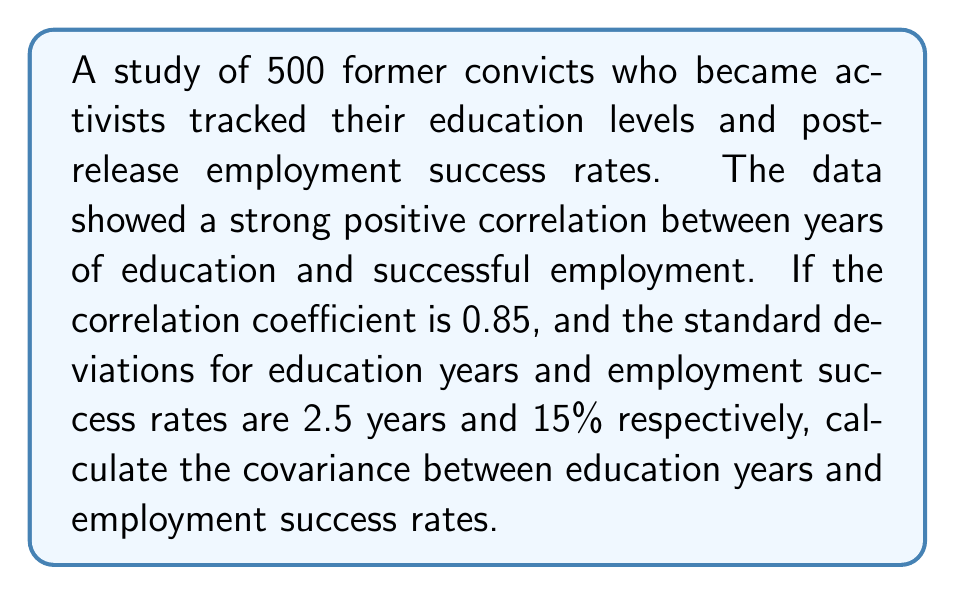Show me your answer to this math problem. To solve this problem, we'll use the formula for the correlation coefficient in terms of covariance and standard deviations:

$$r = \frac{\text{Cov}(X,Y)}{\sigma_X \sigma_Y}$$

Where:
$r$ is the correlation coefficient
$\text{Cov}(X,Y)$ is the covariance between X and Y
$\sigma_X$ is the standard deviation of X
$\sigma_Y$ is the standard deviation of Y

We're given:
$r = 0.85$
$\sigma_X = 2.5$ years (education)
$\sigma_Y = 15\%$ (employment success rate)

Let's rearrange the formula to solve for covariance:

$$\text{Cov}(X,Y) = r \cdot \sigma_X \cdot \sigma_Y$$

Now, we can substitute the known values:

$$\text{Cov}(X,Y) = 0.85 \cdot 2.5 \cdot 15$$

Calculating:

$$\text{Cov}(X,Y) = 31.875$$

The units for covariance are the product of the units of the two variables, so in this case, it's years * percentage.
Answer: $31.875$ years * percentage 